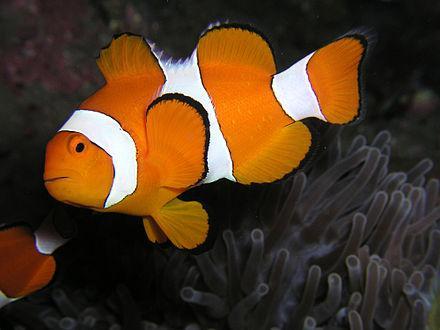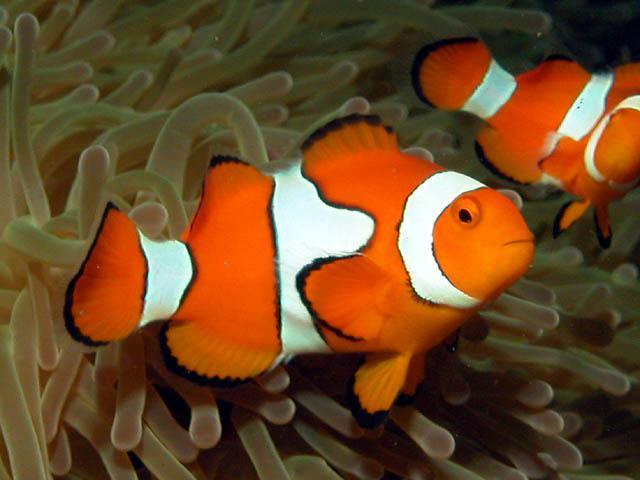The first image is the image on the left, the second image is the image on the right. Given the left and right images, does the statement "The clown fish in the left and right images face toward each other." hold true? Answer yes or no. No. 